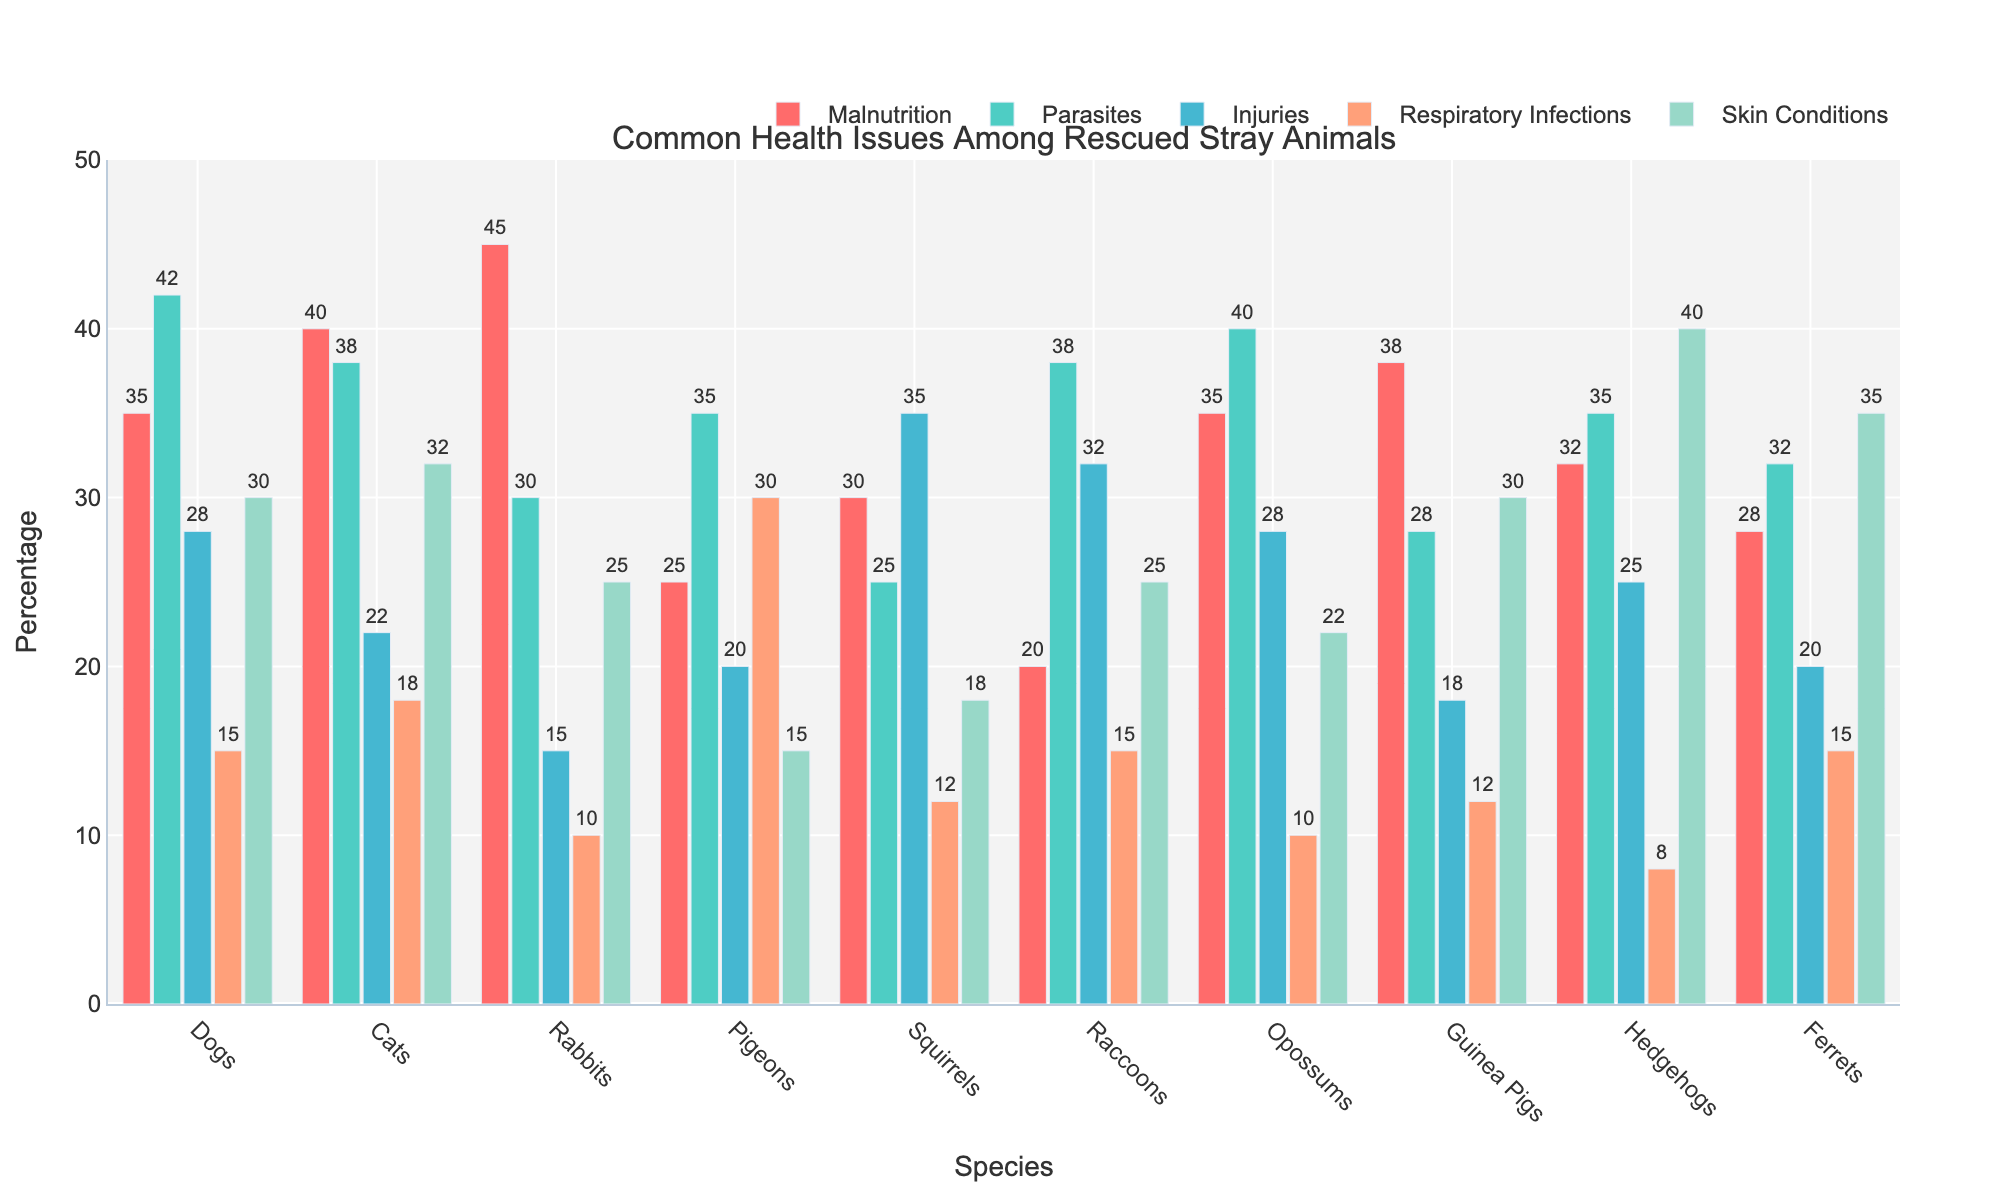Which species has the highest percentage of malnutrition cases? Observing the highest bar associated with malnutrition, the rabbits have the highest percentage (45%).
Answer: Rabbits Which two species have the same percentage of injuries? Looking at the bars for injuries across species, dogs and opossums both have injuries at 28%.
Answer: Dogs and Opossums What is the average percentage of respiratory infections across all species? Sum the percentages of respiratory infections (15 + 18 + 10 + 30 + 12 + 15 + 10 + 12 + 8 + 15) and divide by the number of species (10). (15 + 18 + 10 + 30 + 12 + 15 + 10 + 12 + 8 + 15) = 145. Then, 145 / 10 = 14.5.
Answer: 14.5 Which health issue has the most consistent distribution across species? By visually comparing the heights of the bars for each health issue, skin conditions do not show extreme variation across species compared to others.
Answer: Skin Conditions What is the total percentage of parasites in all rodent species listed (rabbits, squirrels, guinea pigs)? Sum the percentages of parasites in rabbits (30), squirrels (25), and guinea pigs (28). 30 + 25 + 28 = 83.
Answer: 83 Which species has the lowest combined percentage for malnutrition and respiratory infections? Combine malnutrition and respiratory infections percentages for each species, and determine the lowest: 
- Dogs: 35 + 15 = 50
- Cats: 40 + 18 = 58
- Rabbits: 45 + 10 = 55
- Pigeons: 25 + 30 = 55
- Squirrels: 30 + 12 = 42
- Raccoons: 20 + 15 = 35
- Opossums: 35 + 10 = 45
- Guinea Pigs: 38 + 12 = 50
- Hedgehogs: 32 + 8 = 40
- Ferrets: 28 + 15 = 43 
The lowest is 35 for raccoons.
Answer: Raccoons Which health issue shows a noticeably higher instance in ferrets compared to rabbits? Comparing each health issue, the bar for skin conditions is significantly higher in ferrets (35%) compared to rabbits (25%).
Answer: Skin Conditions Which species have a higher percentage of respiratory infections than injuries? Compare respiratory infections and injuries for each species. Pigeons (30 > 20) and Hedgehogs (8 < 25) have higher percentages of respiratory infections than injuries.
Answer: Pigeons What is the difference in the percentage of malnutrition cases between cats and opossums? Subtract the percentage of malnutrition in opossums (35%) from that in cats (40%), resulting in a 5% difference.
Answer: 5 How many species have over 30% cases of parasites? By viewing the bars for parasites, the species with over 30% cases are dogs (42), cats (38), pigeons (35), raccoons (38), opossums (40), and ferrets (32). There are 6 species in total.
Answer: 6 